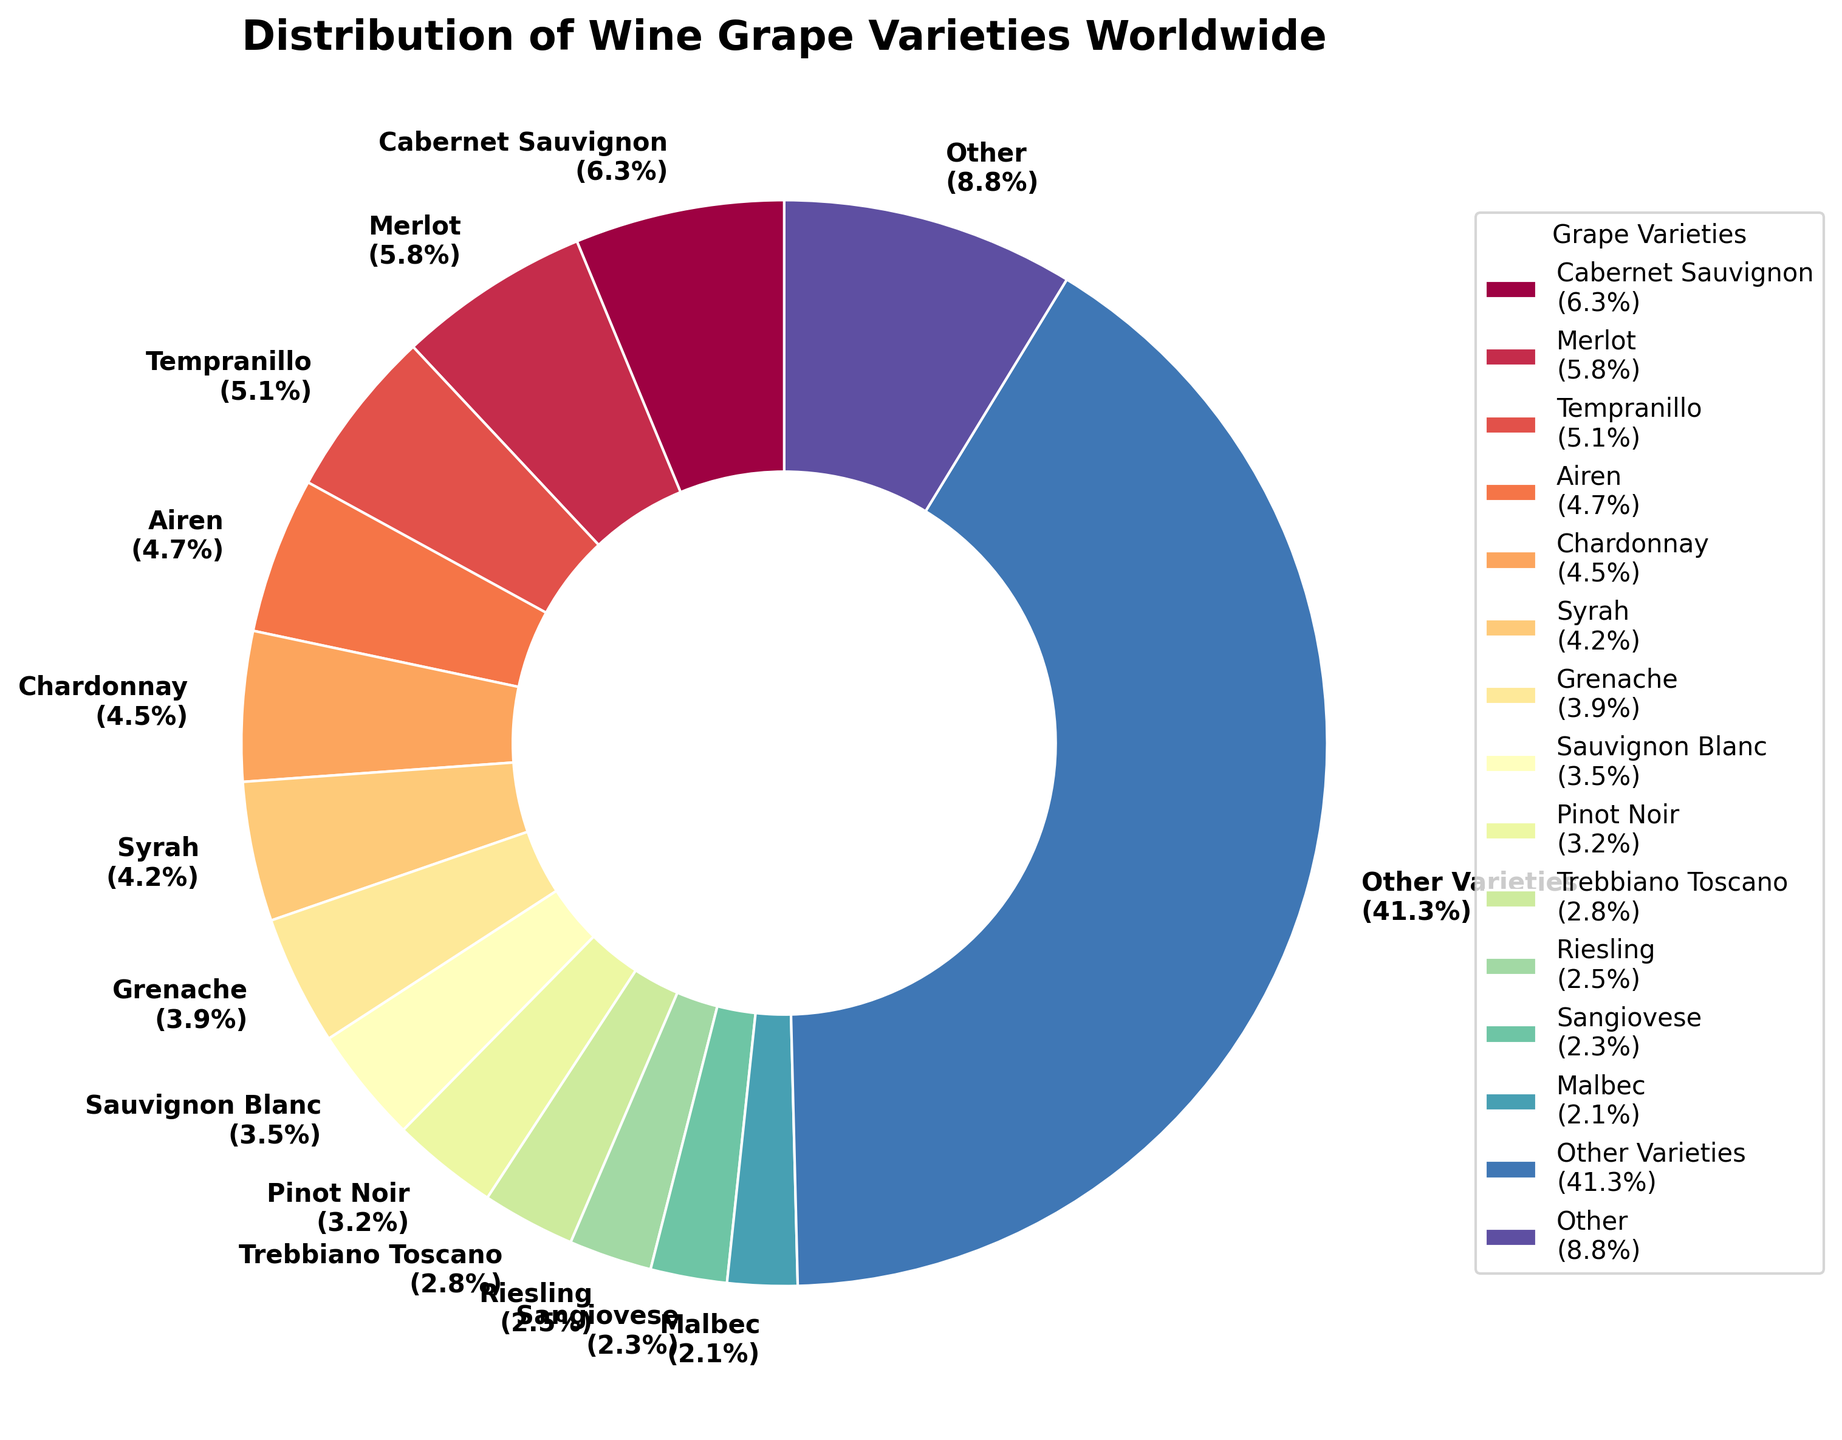Is Cabernet Sauvignon the most widely grown grape variety worldwide? Look at the pie chart and find the segment labeled "Cabernet Sauvignon". Verify if it has the highest percentage compared to other segments.
Answer: Yes Which two grape varieties have the next highest percentages after "Cabernet Sauvignon"? Find the segment labeled "Cabernet Sauvignon" and then identify the two segments with the next highest percentages, which are "Merlot" and "Tempranillo".
Answer: Merlot and Tempranillo What is the combined percentage of "Chardonnay" and "Syrah"? Locate the percentages for "Chardonnay" (4.5%) and "Syrah" (4.2%) in their respective segments, then add these two values together.
Answer: 8.7% How does the percentage of "Grenache" compare to "Sauvignon Blanc"? Locate the segments and their percentages for "Grenache" (3.9%) and "Sauvignon Blanc" (3.5%), and then compare them.
Answer: Grenache has a higher percentage than Sauvignon Blanc What is the difference in percentage between "Pinot Noir" and "Sangiovese"? Find the percentages for "Pinot Noir" (3.2%) and "Sangiovese" (2.3%), then subtract the smaller percentage from the larger.
Answer: 0.9% Which grape varieties are included in the "Other" category and what is its total percentage? Sum the percentages of grape varieties with less than 2.0% to get the "Other" category, which is visually represented as a single segment with a total percentage. The chart lists this total percentage for "Other".
Answer: 41.3% Which grape variety has the smallest percentage shown individually in the pie chart? Identify the segment with the smallest percentage that is still labeled individually, not part of the "Other" category. This is "Malbec".
Answer: Malbec How many grape varieties individually listed have a percentage of 3.0% or more? Count the segments with percentages equal to or greater than 3.0%, including "Cabernet Sauvignon", "Merlot", "Tempranillo", "Airen", "Chardonnay", "Syrah", "Grenache", and "Sauvignon Blanc".
Answer: 8 